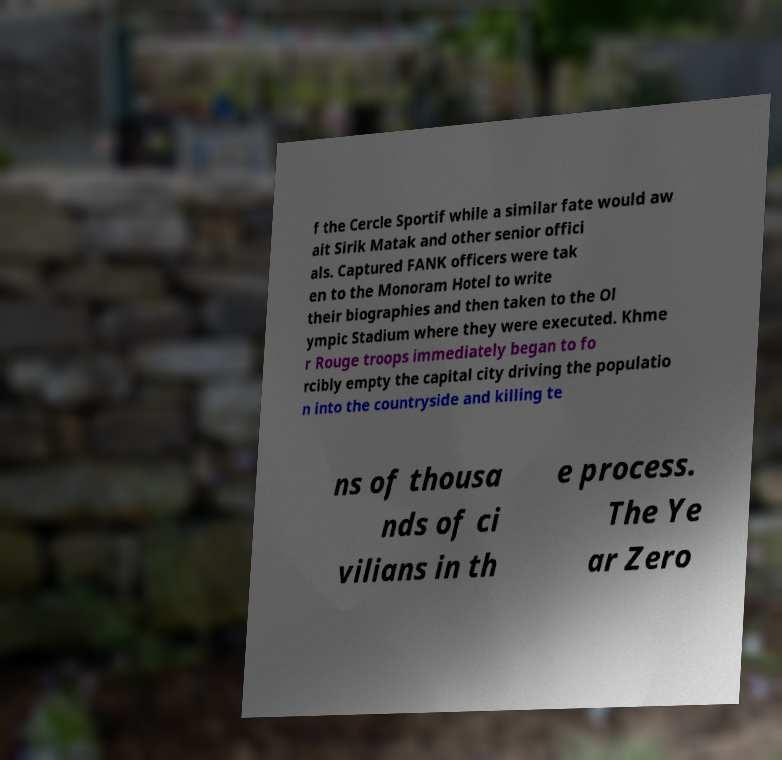I need the written content from this picture converted into text. Can you do that? f the Cercle Sportif while a similar fate would aw ait Sirik Matak and other senior offici als. Captured FANK officers were tak en to the Monoram Hotel to write their biographies and then taken to the Ol ympic Stadium where they were executed. Khme r Rouge troops immediately began to fo rcibly empty the capital city driving the populatio n into the countryside and killing te ns of thousa nds of ci vilians in th e process. The Ye ar Zero 